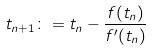<formula> <loc_0><loc_0><loc_500><loc_500>t _ { n + 1 } \colon = t _ { n } - \frac { f ( t _ { n } ) } { f ^ { \prime } ( t _ { n } ) }</formula> 